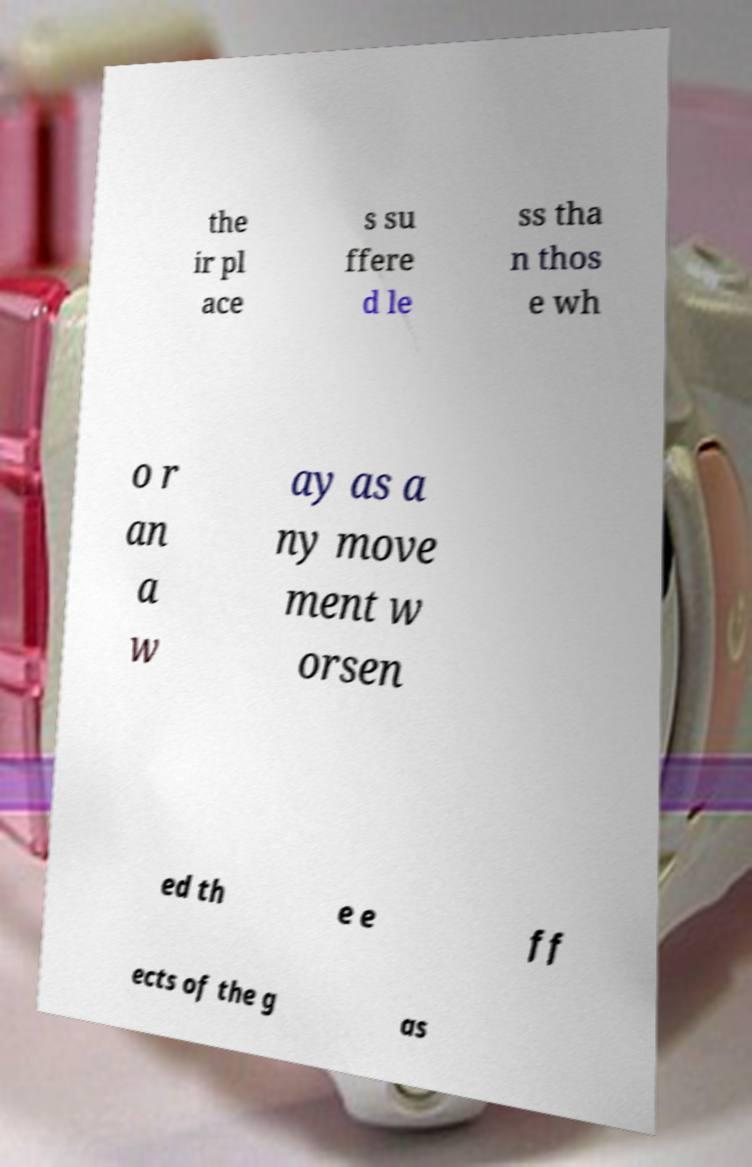I need the written content from this picture converted into text. Can you do that? the ir pl ace s su ffere d le ss tha n thos e wh o r an a w ay as a ny move ment w orsen ed th e e ff ects of the g as 